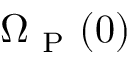<formula> <loc_0><loc_0><loc_500><loc_500>\Omega _ { P } ( { 0 } )</formula> 